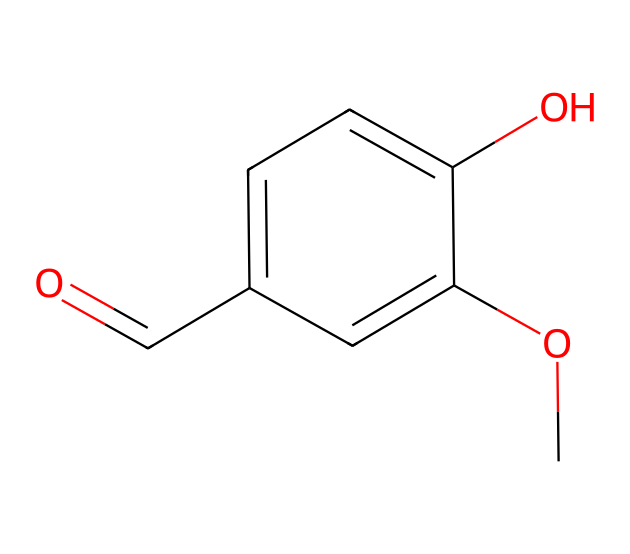What is the common name of the compound represented by this SMILES? The SMILES notation corresponds to a chemical structure known as vanillin, which is recognized for its flavoring properties.
Answer: vanillin How many oxygen atoms are present in the structure? By examining the SMILES, we find that there are two oxygen atoms represented (one in the carbonyl group and another in the methoxy group).
Answer: 2 What type of functional group is present in this compound? In the structure, there is a carbonyl group (C=O), which is characteristic of aldehydes, along with a methoxy group (O-CH3) indicating the presence of an ether.
Answer: aldehyde Are there geometric isomers of this compound? The arrangement of substituents around the double bond (if present) can lead to different geometric isomers; however, this specific compound does not have a structure that allows for such isomerism because it lacks a carbon-carbon double bond.
Answer: no How many rings are in the structure? The SMILES depicts a linear structure of a phenolic compound with no closed-loop formations, meaning there are zero rings in this structure.
Answer: 0 What types of geometric isomers might this compound theoretically have? While the compound itself does not exhibit geometric isomerism due to the absence of carbon-carbon double bonds, if it had such bonds, it could potentially show cis/trans isomerism depending on the arrangement of substituents.
Answer: none 